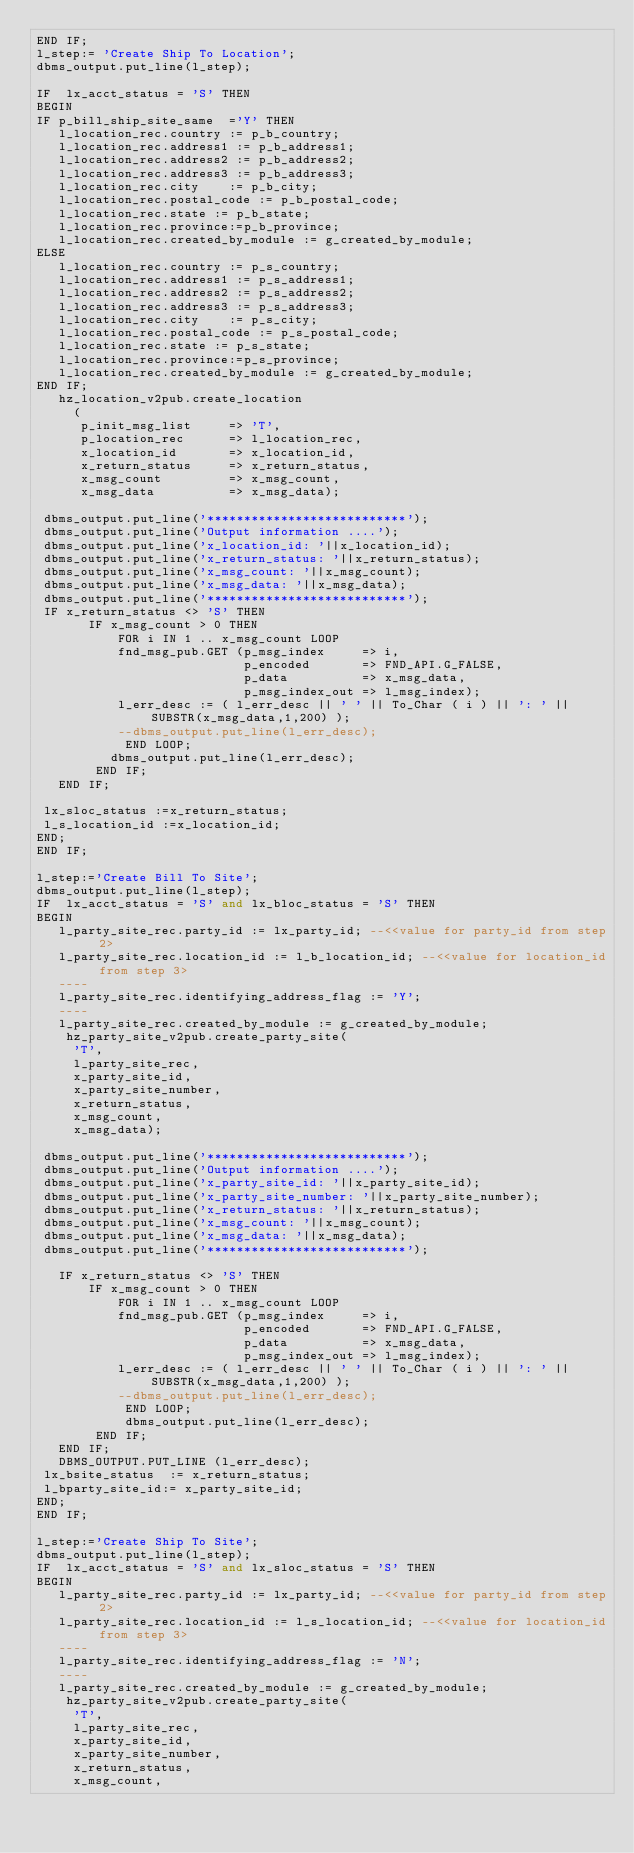Convert code to text. <code><loc_0><loc_0><loc_500><loc_500><_SQL_>END IF;
l_step:= 'Create Ship To Location';
dbms_output.put_line(l_step);

IF  lx_acct_status = 'S' THEN  
BEGIN
IF p_bill_ship_site_same  ='Y' THEN 
   l_location_rec.country := p_b_country;
   l_location_rec.address1 := p_b_address1;
   l_location_rec.address2 := p_b_address2;
   l_location_rec.address3 := p_b_address3;
   l_location_rec.city    := p_b_city;
   l_location_rec.postal_code := p_b_postal_code;
   l_location_rec.state := p_b_state;
   l_location_rec.province:=p_b_province;
   l_location_rec.created_by_module := g_created_by_module;
ELSE
   l_location_rec.country := p_s_country;
   l_location_rec.address1 := p_s_address1;
   l_location_rec.address2 := p_s_address2;
   l_location_rec.address3 := p_s_address3;
   l_location_rec.city    := p_s_city;
   l_location_rec.postal_code := p_s_postal_code;
   l_location_rec.state := p_s_state;
   l_location_rec.province:=p_s_province;
   l_location_rec.created_by_module := g_created_by_module;
END IF;   
   hz_location_v2pub.create_location
     (
      p_init_msg_list     => 'T',
      p_location_rec      => l_location_rec,
      x_location_id       => x_location_id,
      x_return_status     => x_return_status,
      x_msg_count         => x_msg_count,
      x_msg_data          => x_msg_data);

 dbms_output.put_line('***************************');
 dbms_output.put_line('Output information ....');
 dbms_output.put_line('x_location_id: '||x_location_id);
 dbms_output.put_line('x_return_status: '||x_return_status);
 dbms_output.put_line('x_msg_count: '||x_msg_count);
 dbms_output.put_line('x_msg_data: '||x_msg_data);
 dbms_output.put_line('***************************');
 IF x_return_status <> 'S' THEN
       IF x_msg_count > 0 THEN
           FOR i IN 1 .. x_msg_count LOOP
           fnd_msg_pub.GET (p_msg_index     => i,
                            p_encoded       => FND_API.G_FALSE,
                            p_data          => x_msg_data,
                            p_msg_index_out => l_msg_index);
           l_err_desc := ( l_err_desc || ' ' || To_Char ( i ) || ': ' || SUBSTR(x_msg_data,1,200) );
           --dbms_output.put_line(l_err_desc);
            END LOOP;
          dbms_output.put_line(l_err_desc);  
        END IF;
   END IF;
 
 lx_sloc_status :=x_return_status;
 l_s_location_id :=x_location_id;
END; 
END IF;

l_step:='Create Bill To Site';
dbms_output.put_line(l_step);
IF  lx_acct_status = 'S' and lx_bloc_status = 'S' THEN
BEGIN
   l_party_site_rec.party_id := lx_party_id; --<<value for party_id from step 2>
   l_party_site_rec.location_id := l_b_location_id; --<<value for location_id from step 3>
   ----
   l_party_site_rec.identifying_address_flag := 'Y';
   ----
   l_party_site_rec.created_by_module := g_created_by_module;
    hz_party_site_v2pub.create_party_site(
     'T',
     l_party_site_rec,
     x_party_site_id,
     x_party_site_number,
     x_return_status,
     x_msg_count,
     x_msg_data);

 dbms_output.put_line('***************************');
 dbms_output.put_line('Output information ....');
 dbms_output.put_line('x_party_site_id: '||x_party_site_id);
 dbms_output.put_line('x_party_site_number: '||x_party_site_number);
 dbms_output.put_line('x_return_status: '||x_return_status);
 dbms_output.put_line('x_msg_count: '||x_msg_count);
 dbms_output.put_line('x_msg_data: '||x_msg_data);
 dbms_output.put_line('***************************');
 
   IF x_return_status <> 'S' THEN
       IF x_msg_count > 0 THEN
           FOR i IN 1 .. x_msg_count LOOP
           fnd_msg_pub.GET (p_msg_index     => i,
                            p_encoded       => FND_API.G_FALSE,
                            p_data          => x_msg_data,
                            p_msg_index_out => l_msg_index);
           l_err_desc := ( l_err_desc || ' ' || To_Char ( i ) || ': ' || SUBSTR(x_msg_data,1,200) );
           --dbms_output.put_line(l_err_desc);
            END LOOP;
            dbms_output.put_line(l_err_desc);
        END IF;
   END IF;
   DBMS_OUTPUT.PUT_LINE (l_err_desc);
 lx_bsite_status  := x_return_status;
 l_bparty_site_id:= x_party_site_id;
END; 
END IF;

l_step:='Create Ship To Site';
dbms_output.put_line(l_step);
IF  lx_acct_status = 'S' and lx_sloc_status = 'S' THEN
BEGIN
   l_party_site_rec.party_id := lx_party_id; --<<value for party_id from step 2>
   l_party_site_rec.location_id := l_s_location_id; --<<value for location_id from step 3>
   ----
   l_party_site_rec.identifying_address_flag := 'N';
   ----
   l_party_site_rec.created_by_module := g_created_by_module;
    hz_party_site_v2pub.create_party_site(
     'T',
     l_party_site_rec,
     x_party_site_id,
     x_party_site_number,
     x_return_status,
     x_msg_count,</code> 